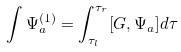<formula> <loc_0><loc_0><loc_500><loc_500>\int \Psi _ { a } ^ { ( 1 ) } = \int _ { \tau _ { l } } ^ { \tau _ { r } } [ G , \Psi _ { a } ] d \tau</formula> 